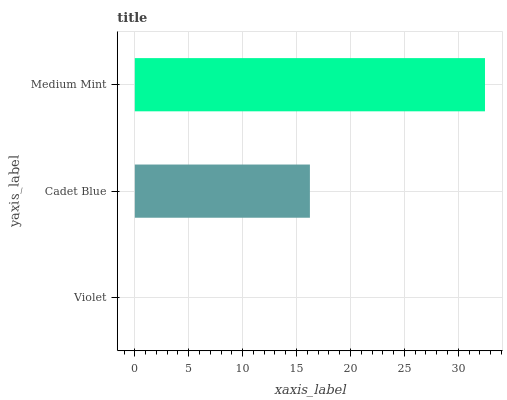Is Violet the minimum?
Answer yes or no. Yes. Is Medium Mint the maximum?
Answer yes or no. Yes. Is Cadet Blue the minimum?
Answer yes or no. No. Is Cadet Blue the maximum?
Answer yes or no. No. Is Cadet Blue greater than Violet?
Answer yes or no. Yes. Is Violet less than Cadet Blue?
Answer yes or no. Yes. Is Violet greater than Cadet Blue?
Answer yes or no. No. Is Cadet Blue less than Violet?
Answer yes or no. No. Is Cadet Blue the high median?
Answer yes or no. Yes. Is Cadet Blue the low median?
Answer yes or no. Yes. Is Medium Mint the high median?
Answer yes or no. No. Is Medium Mint the low median?
Answer yes or no. No. 